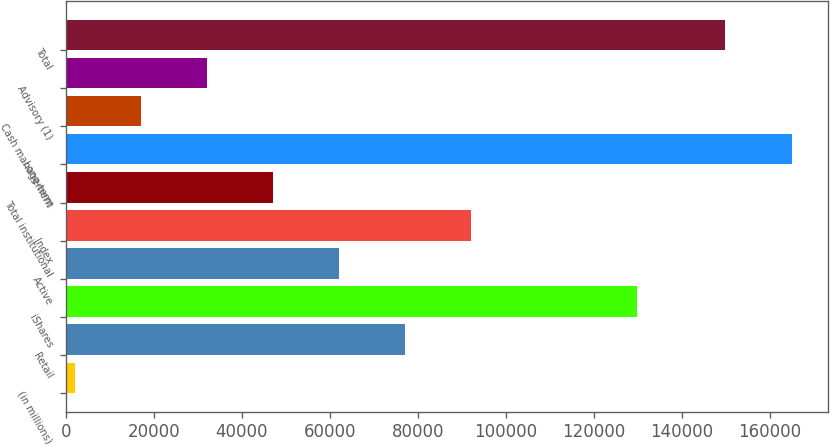Convert chart. <chart><loc_0><loc_0><loc_500><loc_500><bar_chart><fcel>(in millions)<fcel>Retail<fcel>iShares<fcel>Active<fcel>Index<fcel>Total institutional<fcel>Long-term<fcel>Cash management<fcel>Advisory (1)<fcel>Total<nl><fcel>2015<fcel>77014.5<fcel>129852<fcel>62014.6<fcel>92014.4<fcel>47014.7<fcel>164895<fcel>17014.9<fcel>32014.8<fcel>149895<nl></chart> 